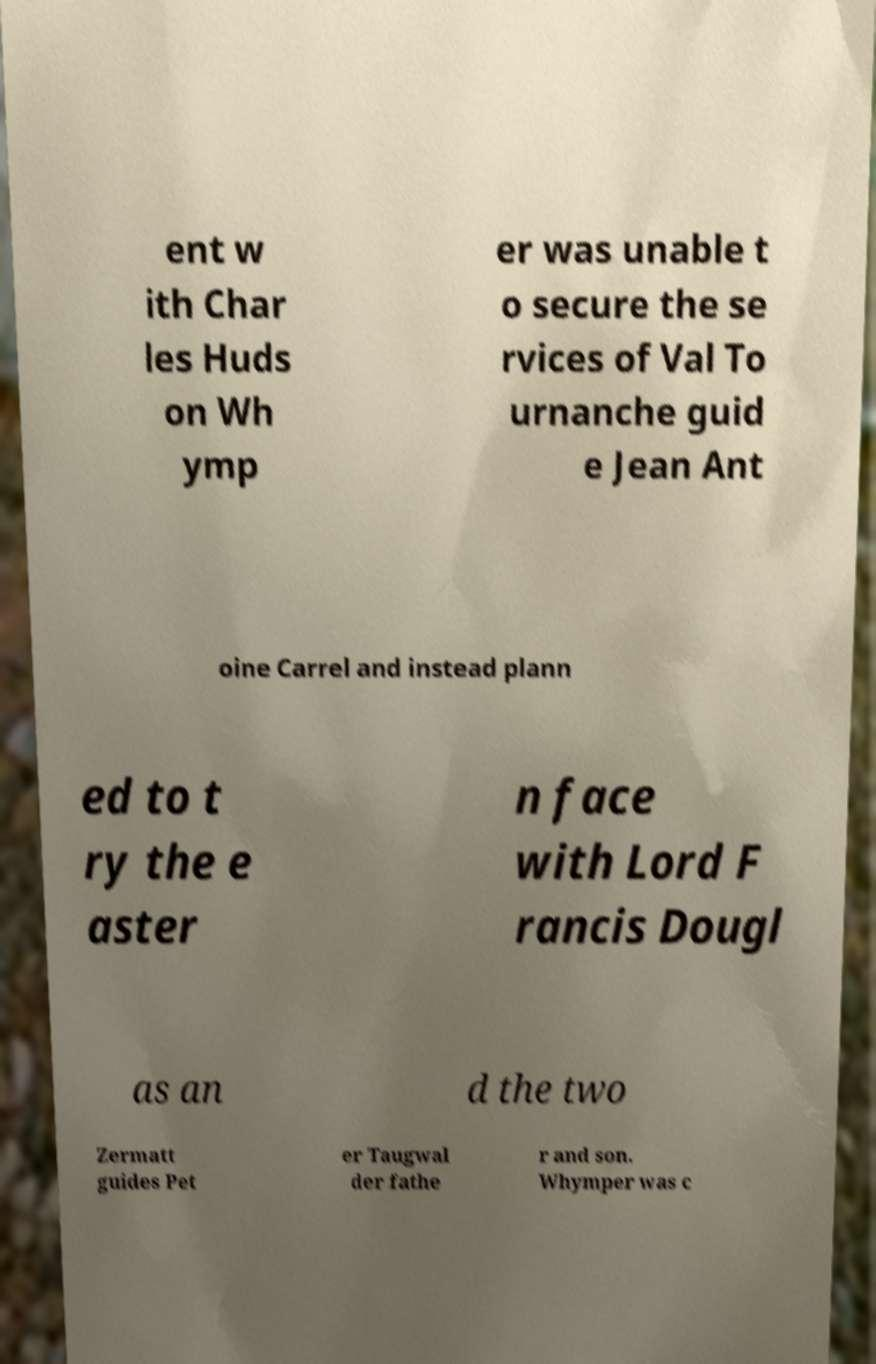For documentation purposes, I need the text within this image transcribed. Could you provide that? ent w ith Char les Huds on Wh ymp er was unable t o secure the se rvices of Val To urnanche guid e Jean Ant oine Carrel and instead plann ed to t ry the e aster n face with Lord F rancis Dougl as an d the two Zermatt guides Pet er Taugwal der fathe r and son. Whymper was c 